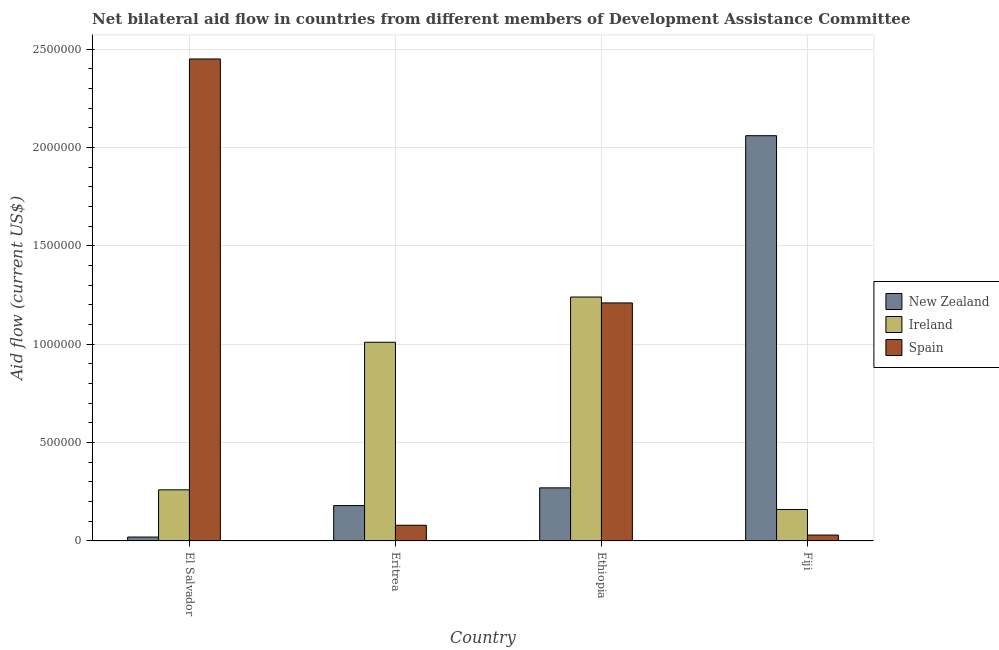How many groups of bars are there?
Give a very brief answer. 4. How many bars are there on the 1st tick from the left?
Make the answer very short. 3. What is the label of the 2nd group of bars from the left?
Make the answer very short. Eritrea. What is the amount of aid provided by ireland in Ethiopia?
Your answer should be compact. 1.24e+06. Across all countries, what is the maximum amount of aid provided by spain?
Your response must be concise. 2.45e+06. Across all countries, what is the minimum amount of aid provided by spain?
Your answer should be very brief. 3.00e+04. In which country was the amount of aid provided by spain maximum?
Your answer should be compact. El Salvador. In which country was the amount of aid provided by new zealand minimum?
Offer a terse response. El Salvador. What is the total amount of aid provided by ireland in the graph?
Make the answer very short. 2.67e+06. What is the difference between the amount of aid provided by new zealand in El Salvador and that in Ethiopia?
Make the answer very short. -2.50e+05. What is the difference between the amount of aid provided by ireland in El Salvador and the amount of aid provided by new zealand in Eritrea?
Offer a very short reply. 8.00e+04. What is the average amount of aid provided by new zealand per country?
Provide a succinct answer. 6.32e+05. What is the difference between the amount of aid provided by ireland and amount of aid provided by new zealand in Eritrea?
Your response must be concise. 8.30e+05. In how many countries, is the amount of aid provided by new zealand greater than 1500000 US$?
Your answer should be compact. 1. What is the ratio of the amount of aid provided by ireland in Eritrea to that in Ethiopia?
Offer a terse response. 0.81. What is the difference between the highest and the second highest amount of aid provided by new zealand?
Provide a short and direct response. 1.79e+06. What is the difference between the highest and the lowest amount of aid provided by new zealand?
Offer a very short reply. 2.04e+06. In how many countries, is the amount of aid provided by ireland greater than the average amount of aid provided by ireland taken over all countries?
Offer a terse response. 2. What does the 1st bar from the left in Fiji represents?
Offer a very short reply. New Zealand. What does the 3rd bar from the right in Fiji represents?
Offer a terse response. New Zealand. Is it the case that in every country, the sum of the amount of aid provided by new zealand and amount of aid provided by ireland is greater than the amount of aid provided by spain?
Offer a terse response. No. How many bars are there?
Your response must be concise. 12. Are all the bars in the graph horizontal?
Ensure brevity in your answer.  No. How many countries are there in the graph?
Your answer should be compact. 4. What is the difference between two consecutive major ticks on the Y-axis?
Give a very brief answer. 5.00e+05. Does the graph contain grids?
Ensure brevity in your answer.  Yes. How many legend labels are there?
Keep it short and to the point. 3. How are the legend labels stacked?
Your answer should be very brief. Vertical. What is the title of the graph?
Keep it short and to the point. Net bilateral aid flow in countries from different members of Development Assistance Committee. Does "Czech Republic" appear as one of the legend labels in the graph?
Provide a short and direct response. No. What is the Aid flow (current US$) in New Zealand in El Salvador?
Your response must be concise. 2.00e+04. What is the Aid flow (current US$) of Ireland in El Salvador?
Your answer should be compact. 2.60e+05. What is the Aid flow (current US$) of Spain in El Salvador?
Offer a terse response. 2.45e+06. What is the Aid flow (current US$) of Ireland in Eritrea?
Make the answer very short. 1.01e+06. What is the Aid flow (current US$) of New Zealand in Ethiopia?
Give a very brief answer. 2.70e+05. What is the Aid flow (current US$) of Ireland in Ethiopia?
Make the answer very short. 1.24e+06. What is the Aid flow (current US$) in Spain in Ethiopia?
Your answer should be compact. 1.21e+06. What is the Aid flow (current US$) in New Zealand in Fiji?
Keep it short and to the point. 2.06e+06. Across all countries, what is the maximum Aid flow (current US$) of New Zealand?
Your answer should be compact. 2.06e+06. Across all countries, what is the maximum Aid flow (current US$) of Ireland?
Your answer should be very brief. 1.24e+06. Across all countries, what is the maximum Aid flow (current US$) of Spain?
Your answer should be compact. 2.45e+06. Across all countries, what is the minimum Aid flow (current US$) in New Zealand?
Provide a succinct answer. 2.00e+04. What is the total Aid flow (current US$) in New Zealand in the graph?
Keep it short and to the point. 2.53e+06. What is the total Aid flow (current US$) in Ireland in the graph?
Provide a short and direct response. 2.67e+06. What is the total Aid flow (current US$) of Spain in the graph?
Ensure brevity in your answer.  3.77e+06. What is the difference between the Aid flow (current US$) in Ireland in El Salvador and that in Eritrea?
Ensure brevity in your answer.  -7.50e+05. What is the difference between the Aid flow (current US$) of Spain in El Salvador and that in Eritrea?
Ensure brevity in your answer.  2.37e+06. What is the difference between the Aid flow (current US$) of Ireland in El Salvador and that in Ethiopia?
Give a very brief answer. -9.80e+05. What is the difference between the Aid flow (current US$) of Spain in El Salvador and that in Ethiopia?
Provide a short and direct response. 1.24e+06. What is the difference between the Aid flow (current US$) of New Zealand in El Salvador and that in Fiji?
Offer a very short reply. -2.04e+06. What is the difference between the Aid flow (current US$) in Spain in El Salvador and that in Fiji?
Make the answer very short. 2.42e+06. What is the difference between the Aid flow (current US$) of New Zealand in Eritrea and that in Ethiopia?
Keep it short and to the point. -9.00e+04. What is the difference between the Aid flow (current US$) of Spain in Eritrea and that in Ethiopia?
Provide a short and direct response. -1.13e+06. What is the difference between the Aid flow (current US$) in New Zealand in Eritrea and that in Fiji?
Keep it short and to the point. -1.88e+06. What is the difference between the Aid flow (current US$) of Ireland in Eritrea and that in Fiji?
Offer a terse response. 8.50e+05. What is the difference between the Aid flow (current US$) of Spain in Eritrea and that in Fiji?
Provide a succinct answer. 5.00e+04. What is the difference between the Aid flow (current US$) in New Zealand in Ethiopia and that in Fiji?
Keep it short and to the point. -1.79e+06. What is the difference between the Aid flow (current US$) of Ireland in Ethiopia and that in Fiji?
Ensure brevity in your answer.  1.08e+06. What is the difference between the Aid flow (current US$) in Spain in Ethiopia and that in Fiji?
Offer a terse response. 1.18e+06. What is the difference between the Aid flow (current US$) of New Zealand in El Salvador and the Aid flow (current US$) of Ireland in Eritrea?
Keep it short and to the point. -9.90e+05. What is the difference between the Aid flow (current US$) in New Zealand in El Salvador and the Aid flow (current US$) in Ireland in Ethiopia?
Your response must be concise. -1.22e+06. What is the difference between the Aid flow (current US$) of New Zealand in El Salvador and the Aid flow (current US$) of Spain in Ethiopia?
Provide a short and direct response. -1.19e+06. What is the difference between the Aid flow (current US$) of Ireland in El Salvador and the Aid flow (current US$) of Spain in Ethiopia?
Offer a terse response. -9.50e+05. What is the difference between the Aid flow (current US$) of New Zealand in El Salvador and the Aid flow (current US$) of Ireland in Fiji?
Provide a short and direct response. -1.40e+05. What is the difference between the Aid flow (current US$) in Ireland in El Salvador and the Aid flow (current US$) in Spain in Fiji?
Provide a short and direct response. 2.30e+05. What is the difference between the Aid flow (current US$) in New Zealand in Eritrea and the Aid flow (current US$) in Ireland in Ethiopia?
Offer a very short reply. -1.06e+06. What is the difference between the Aid flow (current US$) in New Zealand in Eritrea and the Aid flow (current US$) in Spain in Ethiopia?
Your response must be concise. -1.03e+06. What is the difference between the Aid flow (current US$) of Ireland in Eritrea and the Aid flow (current US$) of Spain in Ethiopia?
Offer a terse response. -2.00e+05. What is the difference between the Aid flow (current US$) in New Zealand in Eritrea and the Aid flow (current US$) in Ireland in Fiji?
Offer a terse response. 2.00e+04. What is the difference between the Aid flow (current US$) of Ireland in Eritrea and the Aid flow (current US$) of Spain in Fiji?
Give a very brief answer. 9.80e+05. What is the difference between the Aid flow (current US$) of New Zealand in Ethiopia and the Aid flow (current US$) of Ireland in Fiji?
Provide a short and direct response. 1.10e+05. What is the difference between the Aid flow (current US$) of New Zealand in Ethiopia and the Aid flow (current US$) of Spain in Fiji?
Keep it short and to the point. 2.40e+05. What is the difference between the Aid flow (current US$) in Ireland in Ethiopia and the Aid flow (current US$) in Spain in Fiji?
Your answer should be very brief. 1.21e+06. What is the average Aid flow (current US$) in New Zealand per country?
Make the answer very short. 6.32e+05. What is the average Aid flow (current US$) of Ireland per country?
Provide a short and direct response. 6.68e+05. What is the average Aid flow (current US$) in Spain per country?
Ensure brevity in your answer.  9.42e+05. What is the difference between the Aid flow (current US$) in New Zealand and Aid flow (current US$) in Ireland in El Salvador?
Your response must be concise. -2.40e+05. What is the difference between the Aid flow (current US$) in New Zealand and Aid flow (current US$) in Spain in El Salvador?
Provide a succinct answer. -2.43e+06. What is the difference between the Aid flow (current US$) of Ireland and Aid flow (current US$) of Spain in El Salvador?
Provide a succinct answer. -2.19e+06. What is the difference between the Aid flow (current US$) in New Zealand and Aid flow (current US$) in Ireland in Eritrea?
Make the answer very short. -8.30e+05. What is the difference between the Aid flow (current US$) in Ireland and Aid flow (current US$) in Spain in Eritrea?
Offer a terse response. 9.30e+05. What is the difference between the Aid flow (current US$) of New Zealand and Aid flow (current US$) of Ireland in Ethiopia?
Provide a short and direct response. -9.70e+05. What is the difference between the Aid flow (current US$) of New Zealand and Aid flow (current US$) of Spain in Ethiopia?
Give a very brief answer. -9.40e+05. What is the difference between the Aid flow (current US$) in Ireland and Aid flow (current US$) in Spain in Ethiopia?
Your answer should be very brief. 3.00e+04. What is the difference between the Aid flow (current US$) in New Zealand and Aid flow (current US$) in Ireland in Fiji?
Your answer should be very brief. 1.90e+06. What is the difference between the Aid flow (current US$) of New Zealand and Aid flow (current US$) of Spain in Fiji?
Your answer should be very brief. 2.03e+06. What is the ratio of the Aid flow (current US$) of New Zealand in El Salvador to that in Eritrea?
Your answer should be compact. 0.11. What is the ratio of the Aid flow (current US$) in Ireland in El Salvador to that in Eritrea?
Your answer should be very brief. 0.26. What is the ratio of the Aid flow (current US$) of Spain in El Salvador to that in Eritrea?
Provide a succinct answer. 30.62. What is the ratio of the Aid flow (current US$) of New Zealand in El Salvador to that in Ethiopia?
Offer a very short reply. 0.07. What is the ratio of the Aid flow (current US$) in Ireland in El Salvador to that in Ethiopia?
Make the answer very short. 0.21. What is the ratio of the Aid flow (current US$) of Spain in El Salvador to that in Ethiopia?
Keep it short and to the point. 2.02. What is the ratio of the Aid flow (current US$) of New Zealand in El Salvador to that in Fiji?
Ensure brevity in your answer.  0.01. What is the ratio of the Aid flow (current US$) of Ireland in El Salvador to that in Fiji?
Give a very brief answer. 1.62. What is the ratio of the Aid flow (current US$) of Spain in El Salvador to that in Fiji?
Offer a very short reply. 81.67. What is the ratio of the Aid flow (current US$) of New Zealand in Eritrea to that in Ethiopia?
Provide a short and direct response. 0.67. What is the ratio of the Aid flow (current US$) of Ireland in Eritrea to that in Ethiopia?
Offer a terse response. 0.81. What is the ratio of the Aid flow (current US$) of Spain in Eritrea to that in Ethiopia?
Give a very brief answer. 0.07. What is the ratio of the Aid flow (current US$) in New Zealand in Eritrea to that in Fiji?
Make the answer very short. 0.09. What is the ratio of the Aid flow (current US$) in Ireland in Eritrea to that in Fiji?
Ensure brevity in your answer.  6.31. What is the ratio of the Aid flow (current US$) of Spain in Eritrea to that in Fiji?
Keep it short and to the point. 2.67. What is the ratio of the Aid flow (current US$) of New Zealand in Ethiopia to that in Fiji?
Keep it short and to the point. 0.13. What is the ratio of the Aid flow (current US$) of Ireland in Ethiopia to that in Fiji?
Provide a succinct answer. 7.75. What is the ratio of the Aid flow (current US$) in Spain in Ethiopia to that in Fiji?
Provide a succinct answer. 40.33. What is the difference between the highest and the second highest Aid flow (current US$) in New Zealand?
Your answer should be very brief. 1.79e+06. What is the difference between the highest and the second highest Aid flow (current US$) in Spain?
Offer a very short reply. 1.24e+06. What is the difference between the highest and the lowest Aid flow (current US$) in New Zealand?
Your response must be concise. 2.04e+06. What is the difference between the highest and the lowest Aid flow (current US$) of Ireland?
Your answer should be very brief. 1.08e+06. What is the difference between the highest and the lowest Aid flow (current US$) in Spain?
Keep it short and to the point. 2.42e+06. 